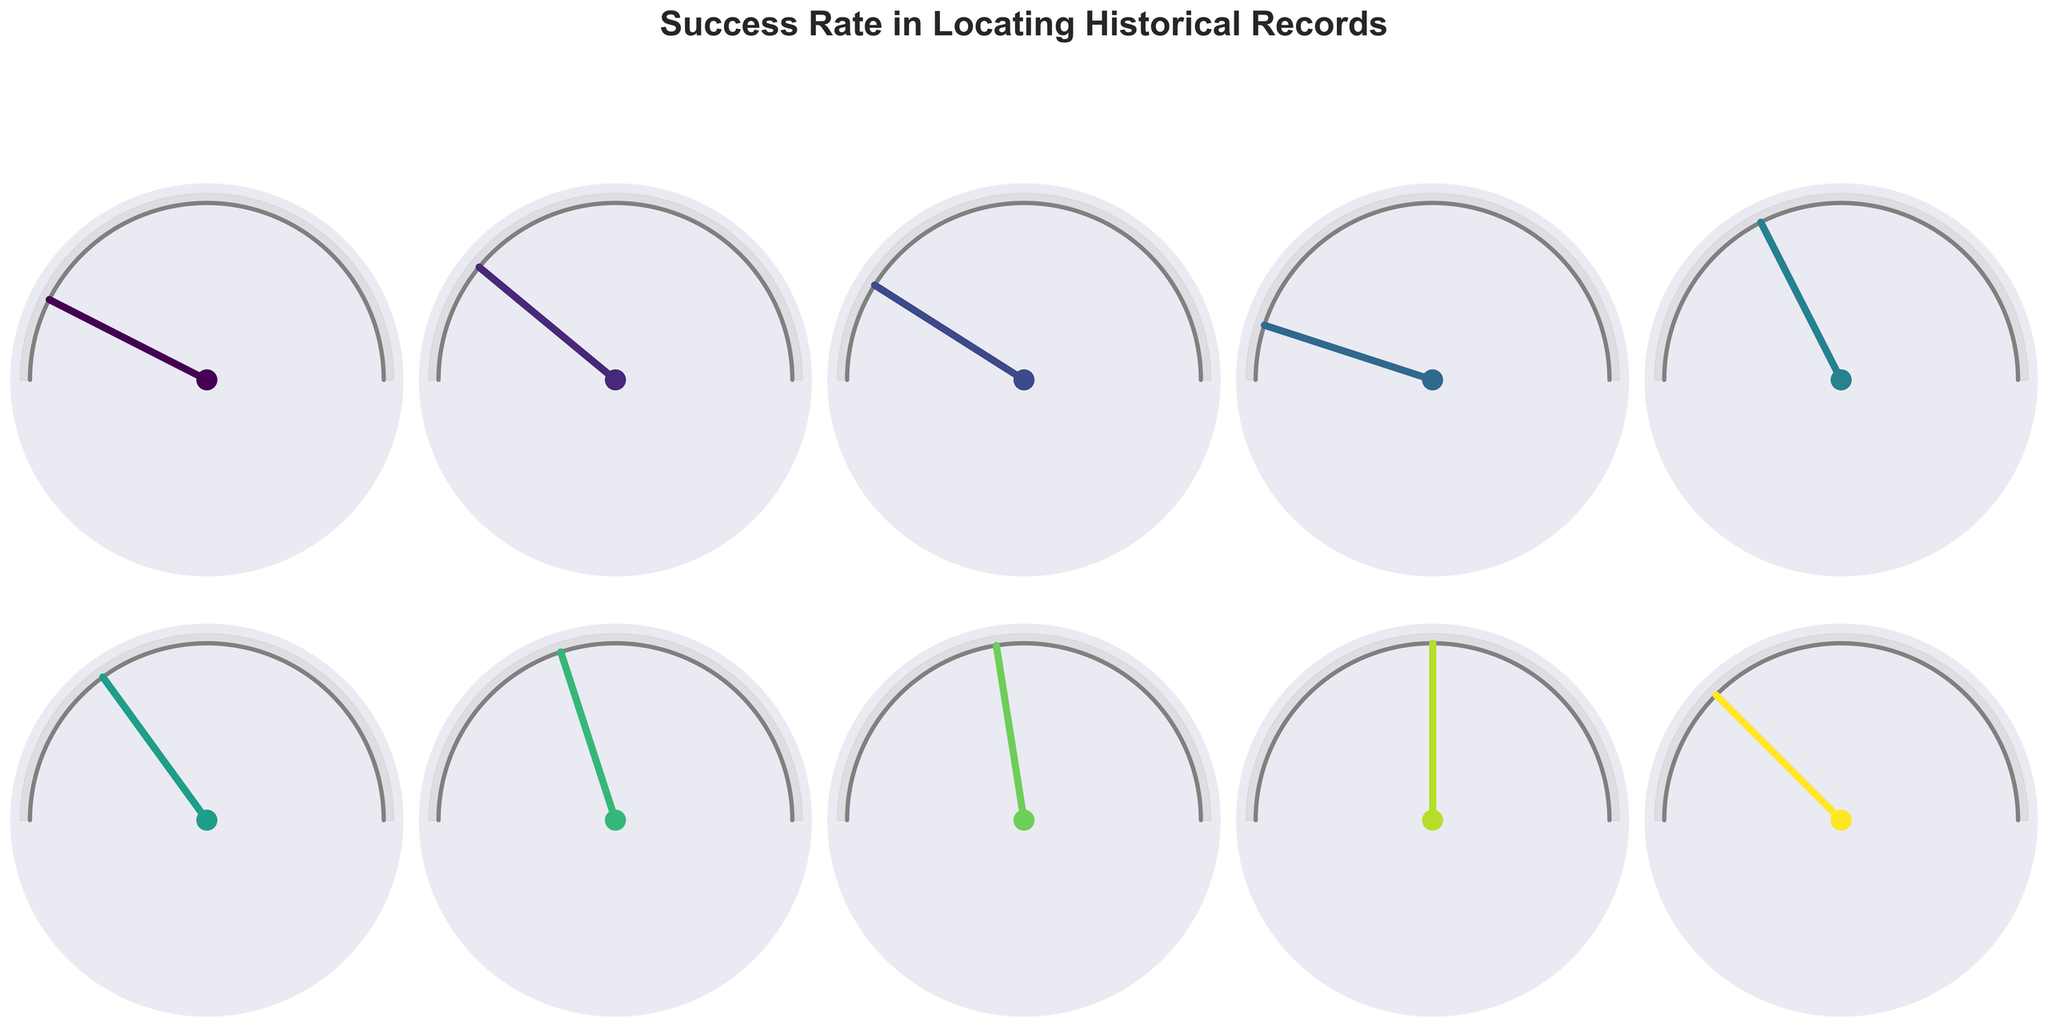Which document type has the highest success rate? By examining the gauge charts, we see that Census Records have the highest success rate at 90%.
Answer: Census Records Which document type has the lowest success rate? By looking at the gauge charts, we can see that Land Deeds have the lowest success rate at 50%.
Answer: Land Deeds How many document types have a success rate of 80% or higher? From the gauge charts, we identify that Birth Certificates (85%), Death Certificates (82%), and Census Records (90%) have a success rate of 80% or higher. The count is 3.
Answer: 3 What is the success rate of Church Registers? The gauge chart for Church Registers indicates a success rate of 65%.
Answer: 65% Which document types have a success rate between 70% and 80%? By analyzing the gauge charts, we see that Marriage Records (78%), Military Service Records (70%), and Newspaper Obituaries (75%) fall within the 70%-80% range.
Answer: Marriage Records, Military Service Records, Newspaper Obituaries What is the average success rate of the top three document types? The top three document types by success rate are Census Records (90%), Birth Certificates (85%), and Death Certificates (82%). The average is calculated as (90 + 85 + 82) / 3 = 85.67.
Answer: 85.67 Which document type is closest to an 80% success rate? Among the gauge charts, Marriage Records have a success rate of 78%, which is closest to 80%.
Answer: Marriage Records How much higher is the success rate for Census Records compared to Immigration Records? The success rate for Census Records is 90%, and for Immigration Records is 60%. The difference is 90 - 60 = 30.
Answer: 30 Which document type has a success rate closest to the median success rate of all document types? Listing the success rates (50, 55, 60, 65, 70, 75, 78, 82, 85, 90), the median is the average of the 5th and 6th values, (70 + 75)/2 = 72.5. The closest document type is Military Service Records with a success rate of 70%.
Answer: Military Service Records 